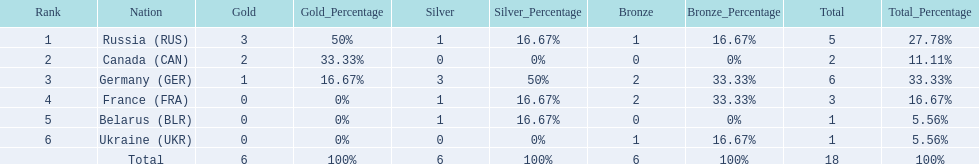Which countries competed in the 1995 biathlon? Russia (RUS), Canada (CAN), Germany (GER), France (FRA), Belarus (BLR), Ukraine (UKR). How many medals in total did they win? 5, 2, 6, 3, 1, 1. And which country had the most? Germany (GER). 